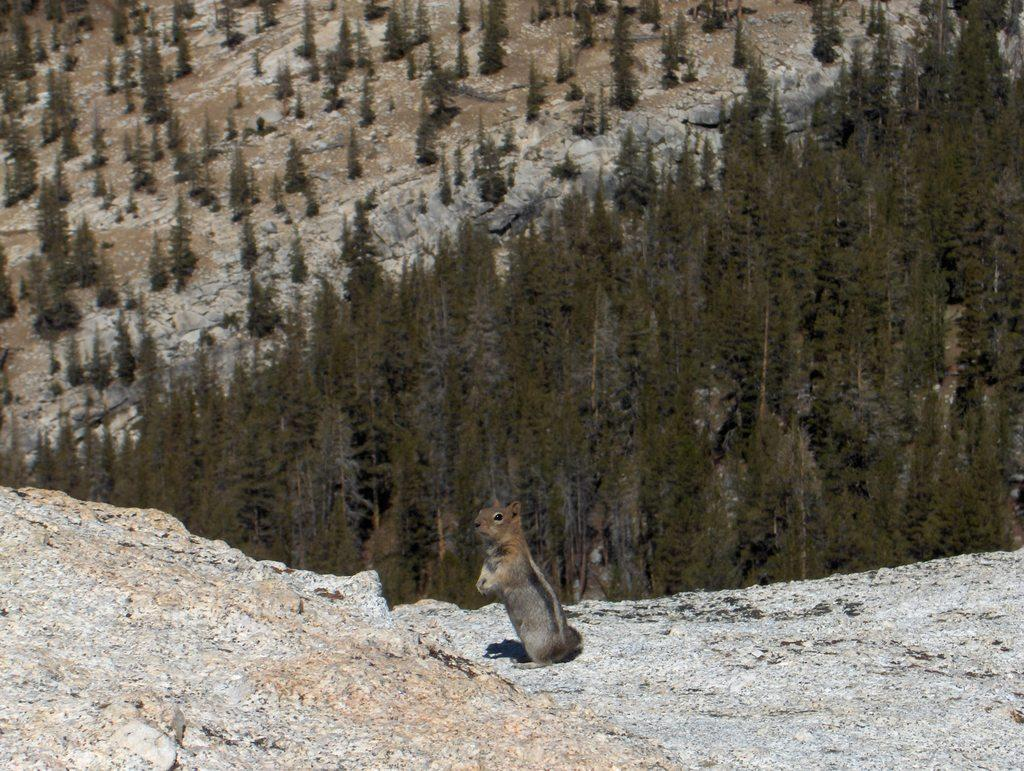What animal is in the center of the image? There is a squirrel in the center of the image. What type of terrain is at the bottom of the image? There is sand at the bottom of the image. What can be seen in the background of the image? There are trees and mountains in the background of the image. Where is the baseball located in the image? There is no baseball present in the image. What type of iron can be seen in the image? There is no iron present in the image. 